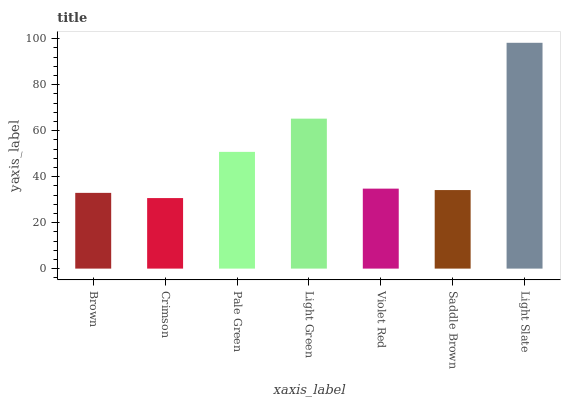Is Crimson the minimum?
Answer yes or no. Yes. Is Light Slate the maximum?
Answer yes or no. Yes. Is Pale Green the minimum?
Answer yes or no. No. Is Pale Green the maximum?
Answer yes or no. No. Is Pale Green greater than Crimson?
Answer yes or no. Yes. Is Crimson less than Pale Green?
Answer yes or no. Yes. Is Crimson greater than Pale Green?
Answer yes or no. No. Is Pale Green less than Crimson?
Answer yes or no. No. Is Violet Red the high median?
Answer yes or no. Yes. Is Violet Red the low median?
Answer yes or no. Yes. Is Pale Green the high median?
Answer yes or no. No. Is Light Slate the low median?
Answer yes or no. No. 